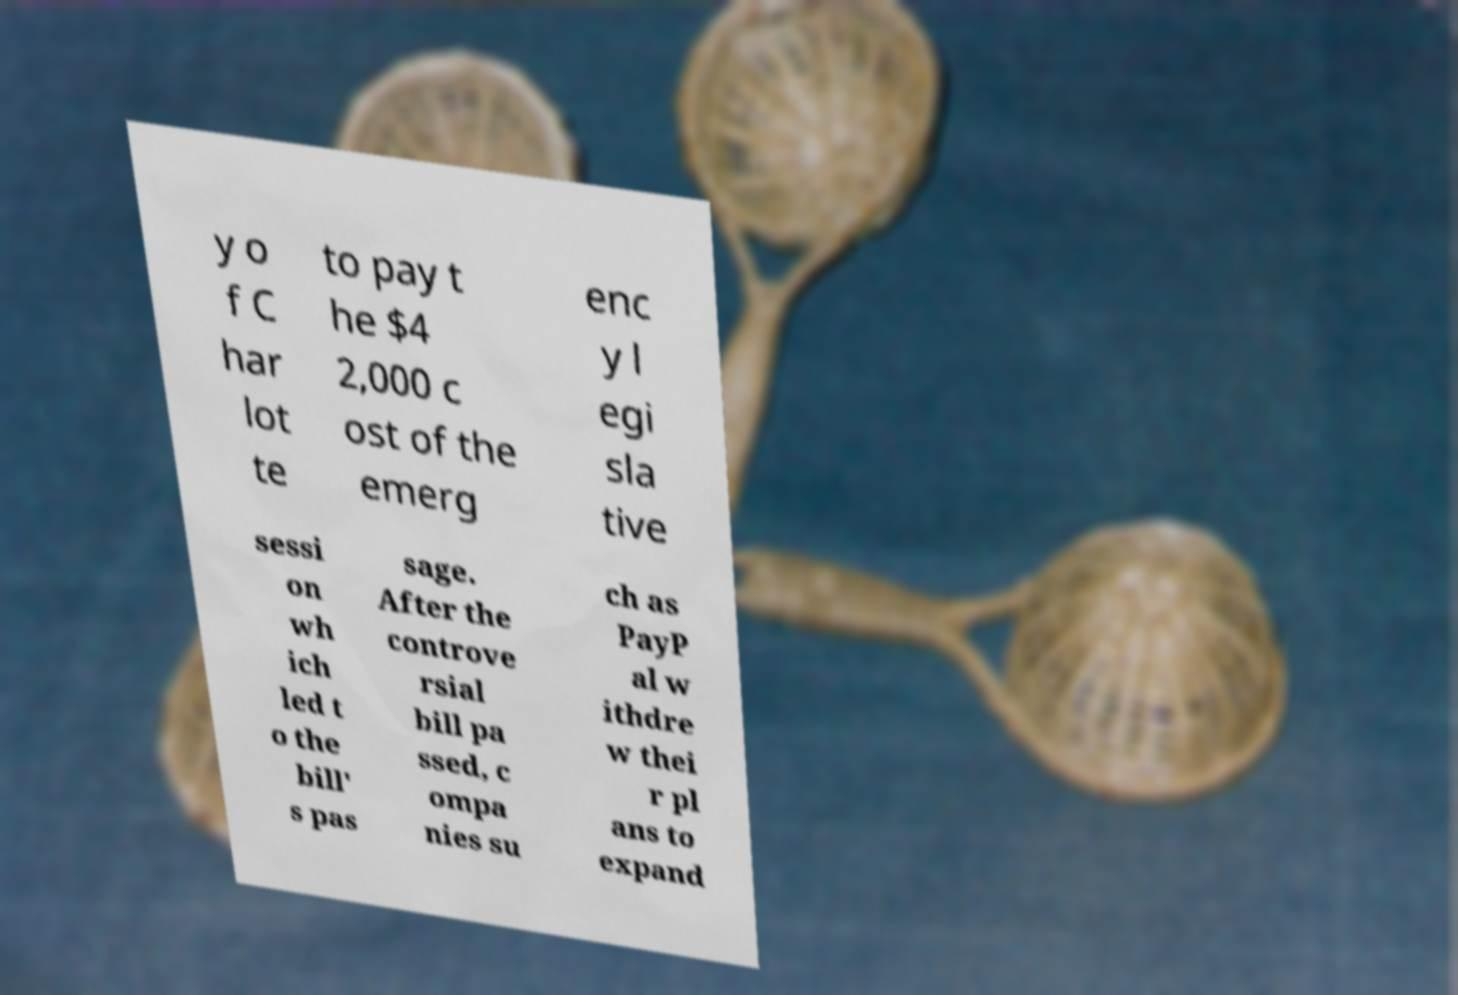What messages or text are displayed in this image? I need them in a readable, typed format. y o f C har lot te to pay t he $4 2,000 c ost of the emerg enc y l egi sla tive sessi on wh ich led t o the bill' s pas sage. After the controve rsial bill pa ssed, c ompa nies su ch as PayP al w ithdre w thei r pl ans to expand 